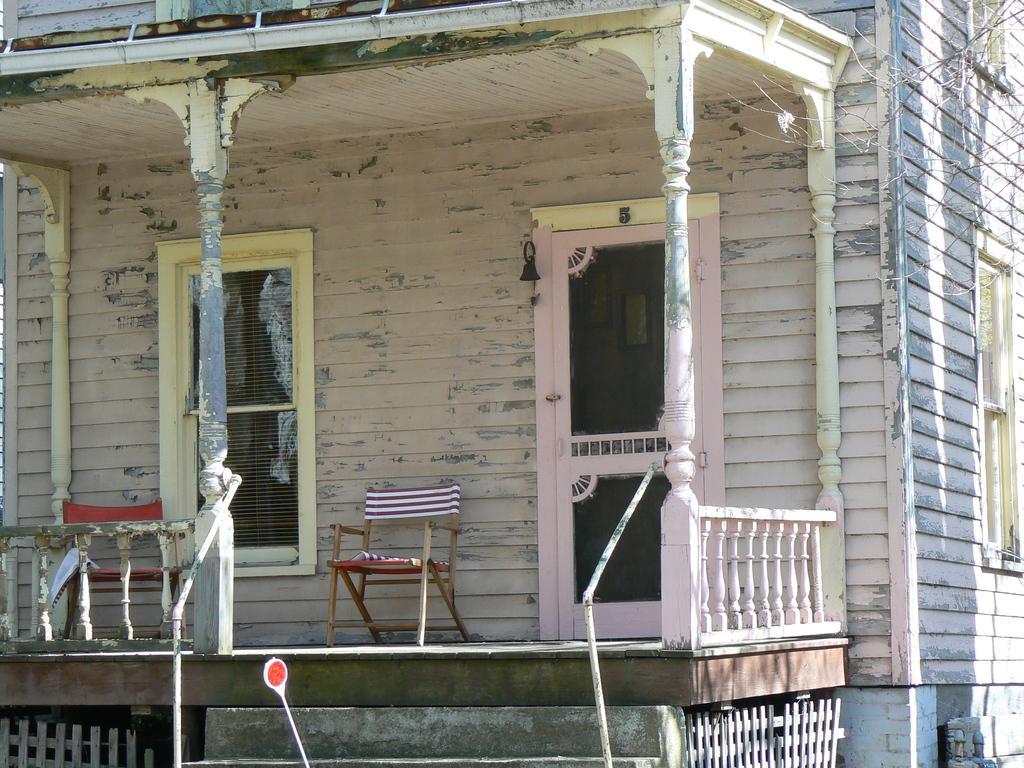How would you summarize this image in a sentence or two? This picture might be taken from outside of the building and it is sunny. In this image, we can see a building, door and a chair in the building. On the right side, we can also see another building. 